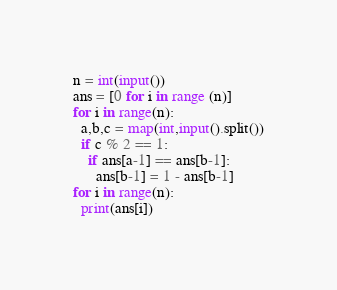Convert code to text. <code><loc_0><loc_0><loc_500><loc_500><_Python_>n = int(input())
ans = [0 for i in range (n)]
for i in range(n):
  a,b,c = map(int,input().split())
  if c % 2 == 1:
    if ans[a-1] == ans[b-1]:
      ans[b-1] = 1 - ans[b-1]
for i in range(n):
  print(ans[i])
</code> 